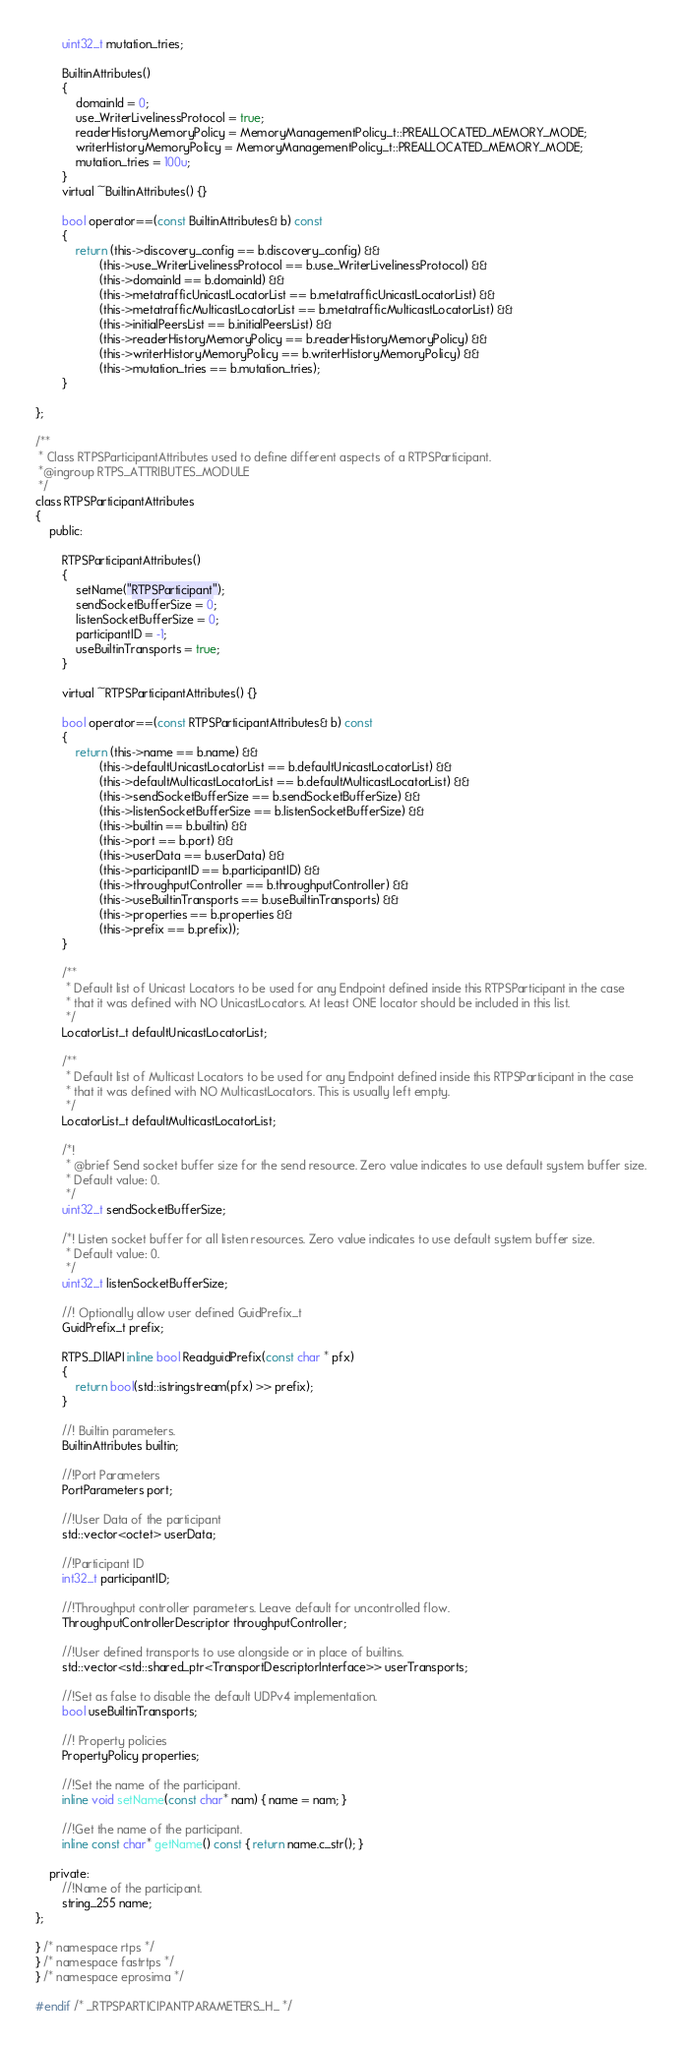<code> <loc_0><loc_0><loc_500><loc_500><_C_>        uint32_t mutation_tries;

        BuiltinAttributes()
        {
            domainId = 0;
            use_WriterLivelinessProtocol = true;
            readerHistoryMemoryPolicy = MemoryManagementPolicy_t::PREALLOCATED_MEMORY_MODE;
            writerHistoryMemoryPolicy = MemoryManagementPolicy_t::PREALLOCATED_MEMORY_MODE;
            mutation_tries = 100u;
        }
        virtual ~BuiltinAttributes() {}

        bool operator==(const BuiltinAttributes& b) const
        {
            return (this->discovery_config == b.discovery_config) &&
                   (this->use_WriterLivelinessProtocol == b.use_WriterLivelinessProtocol) &&
                   (this->domainId == b.domainId) &&
                   (this->metatrafficUnicastLocatorList == b.metatrafficUnicastLocatorList) &&
                   (this->metatrafficMulticastLocatorList == b.metatrafficMulticastLocatorList) &&
                   (this->initialPeersList == b.initialPeersList) &&
                   (this->readerHistoryMemoryPolicy == b.readerHistoryMemoryPolicy) &&
                   (this->writerHistoryMemoryPolicy == b.writerHistoryMemoryPolicy) &&
                   (this->mutation_tries == b.mutation_tries);
        }

};

/**
 * Class RTPSParticipantAttributes used to define different aspects of a RTPSParticipant.
 *@ingroup RTPS_ATTRIBUTES_MODULE
 */
class RTPSParticipantAttributes
{
    public:

        RTPSParticipantAttributes()
        {
            setName("RTPSParticipant");
            sendSocketBufferSize = 0;
            listenSocketBufferSize = 0;
            participantID = -1;
            useBuiltinTransports = true;
        }

        virtual ~RTPSParticipantAttributes() {}

        bool operator==(const RTPSParticipantAttributes& b) const
        {
            return (this->name == b.name) &&
                   (this->defaultUnicastLocatorList == b.defaultUnicastLocatorList) &&
                   (this->defaultMulticastLocatorList == b.defaultMulticastLocatorList) &&
                   (this->sendSocketBufferSize == b.sendSocketBufferSize) &&
                   (this->listenSocketBufferSize == b.listenSocketBufferSize) &&
                   (this->builtin == b.builtin) &&
                   (this->port == b.port) &&
                   (this->userData == b.userData) &&
                   (this->participantID == b.participantID) &&
                   (this->throughputController == b.throughputController) &&
                   (this->useBuiltinTransports == b.useBuiltinTransports) &&
                   (this->properties == b.properties &&
                   (this->prefix == b.prefix));
        }

        /**
         * Default list of Unicast Locators to be used for any Endpoint defined inside this RTPSParticipant in the case
         * that it was defined with NO UnicastLocators. At least ONE locator should be included in this list.
         */
        LocatorList_t defaultUnicastLocatorList;

        /**
         * Default list of Multicast Locators to be used for any Endpoint defined inside this RTPSParticipant in the case
         * that it was defined with NO MulticastLocators. This is usually left empty.
         */
        LocatorList_t defaultMulticastLocatorList;

        /*!
         * @brief Send socket buffer size for the send resource. Zero value indicates to use default system buffer size.
         * Default value: 0.
         */
        uint32_t sendSocketBufferSize;

        /*! Listen socket buffer for all listen resources. Zero value indicates to use default system buffer size.
         * Default value: 0.
         */
        uint32_t listenSocketBufferSize;

        //! Optionally allow user defined GuidPrefix_t
        GuidPrefix_t prefix;

        RTPS_DllAPI inline bool ReadguidPrefix(const char * pfx)
        {
            return bool(std::istringstream(pfx) >> prefix);
        }

        //! Builtin parameters.
        BuiltinAttributes builtin;

        //!Port Parameters
        PortParameters port;

        //!User Data of the participant
        std::vector<octet> userData;

        //!Participant ID
        int32_t participantID;

        //!Throughput controller parameters. Leave default for uncontrolled flow.
        ThroughputControllerDescriptor throughputController;

        //!User defined transports to use alongside or in place of builtins.
        std::vector<std::shared_ptr<TransportDescriptorInterface>> userTransports;

        //!Set as false to disable the default UDPv4 implementation.
        bool useBuiltinTransports;

        //! Property policies
        PropertyPolicy properties;

        //!Set the name of the participant.
        inline void setName(const char* nam) { name = nam; }

        //!Get the name of the participant.
        inline const char* getName() const { return name.c_str(); }

    private:
        //!Name of the participant.
        string_255 name;
};

} /* namespace rtps */
} /* namespace fastrtps */
} /* namespace eprosima */

#endif /* _RTPSPARTICIPANTPARAMETERS_H_ */
</code> 